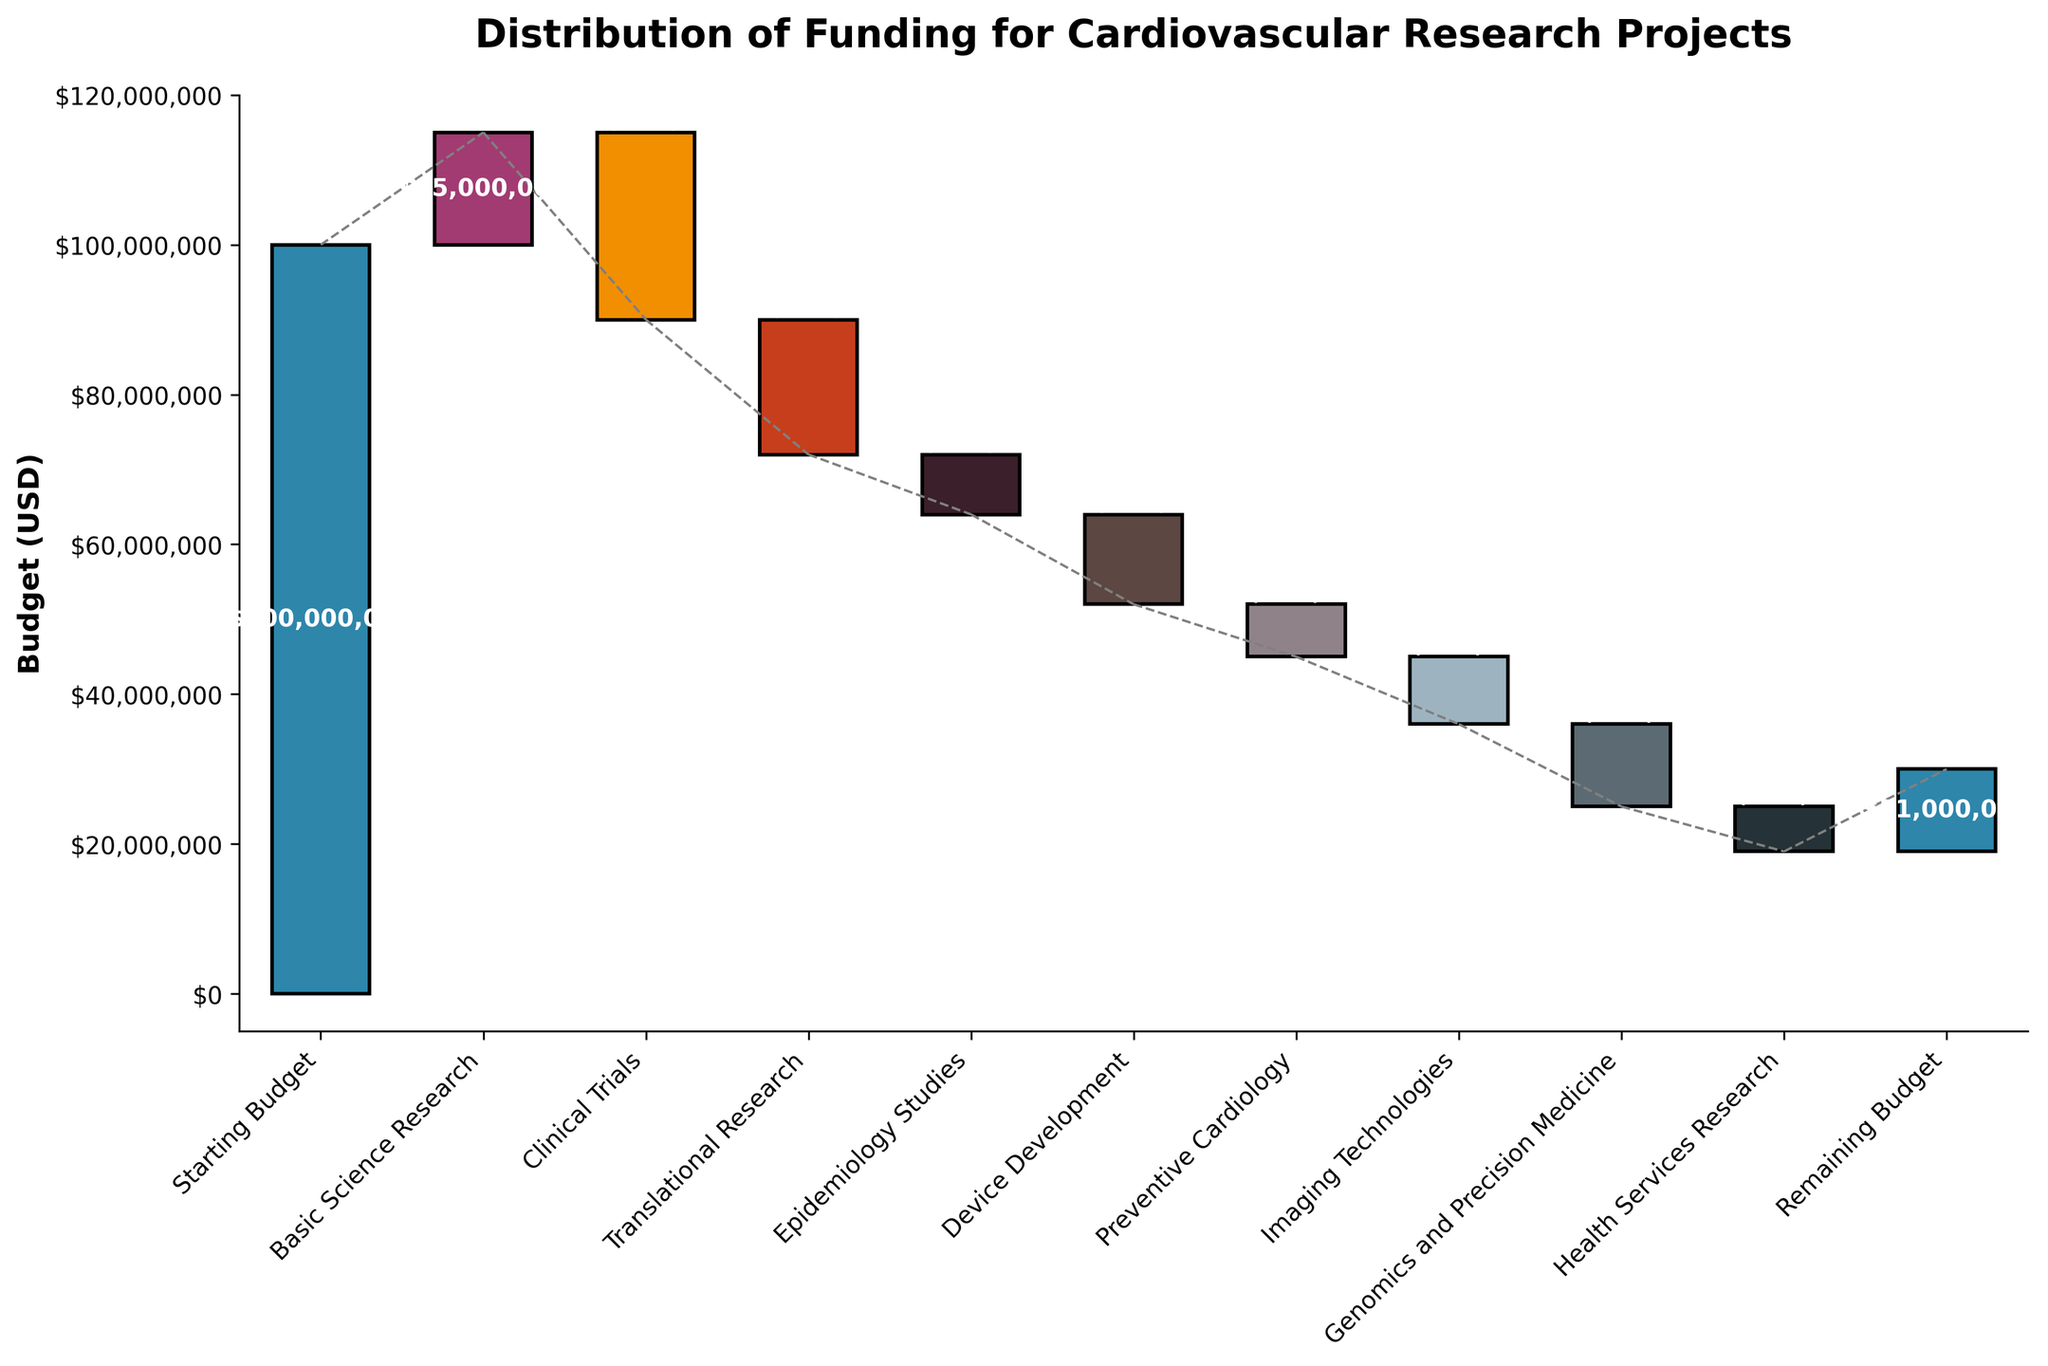What is the title of the chart? The title is located at the top of the chart, reading 'Distribution of Funding for Cardiovascular Research Projects'.
Answer: Distribution of Funding for Cardiovascular Research Projects Which category received the largest positive allocation? By examining the bars rising above the baseline, 'Basic Science Research' has the largest upward value.
Answer: Basic Science Research What is the value for 'Clinical Trials'? 'Clinical Trials' has a downward bar with the label showing a negative value. The bar label displays '($25,000,000)'.
Answer: -25,000,000 How does the funding for 'Translational Research' compare to 'Device Development'? Check both bars representing these categories. 'Translational Research' has a negative $18,000,000 allocation, and 'Device Development' a negative $12,000,000. Translational Research is lower (i.e., it reduces the budget more).
Answer: Translational Research has a larger negative impact by $6,000,000 What is the cumulative effect up to 'Epidemiology Studies'? Sum the bars from the start up to 'Epidemiology Studies'. The incremental values are $100,000,000 - $15,000,000 - $25,000,000 - $18,000,000 - $8,000,000, which totals $34,000,000.
Answer: $34,000,000 What is the final remaining budget after all allocations? The last bar shows the remaining budget, which is indicated as $11,000,000.
Answer: $11,000,000 Which category resulted in reducing the budget by $9,000,000? Look for the category with a bar showing a negative $9,000,000. 'Imaging Technologies' fits this criterion.
Answer: Imaging Technologies Is 'Preventive Cardiology' funded higher or lower than 'Genomics and Precision Medicine'? Compare the two bars. 'Preventive Cardiology' has a negative $7,000,000 allocation, and 'Genomics and Precision Medicine' has a negative $11,000,000 allocation. Hence, 'Preventive Cardiology' reduces the budget less.
Answer: Higher What is the total reduction in budget from all categories? Sum the negative allocations: -$25,000,000 - $18,000,000 - $8,000,000 - $12,000,000 - $7,000,000 - $9,000,000 - $11,000,000 - $6,000,000. This totals -$96,000,000.
Answer: $96,000,000 in total reduction How much was allocated to 'Health Services Research'? The bar corresponding to 'Health Services Research' shows a decrease of $6,000,000.
Answer: -$6,000,000 